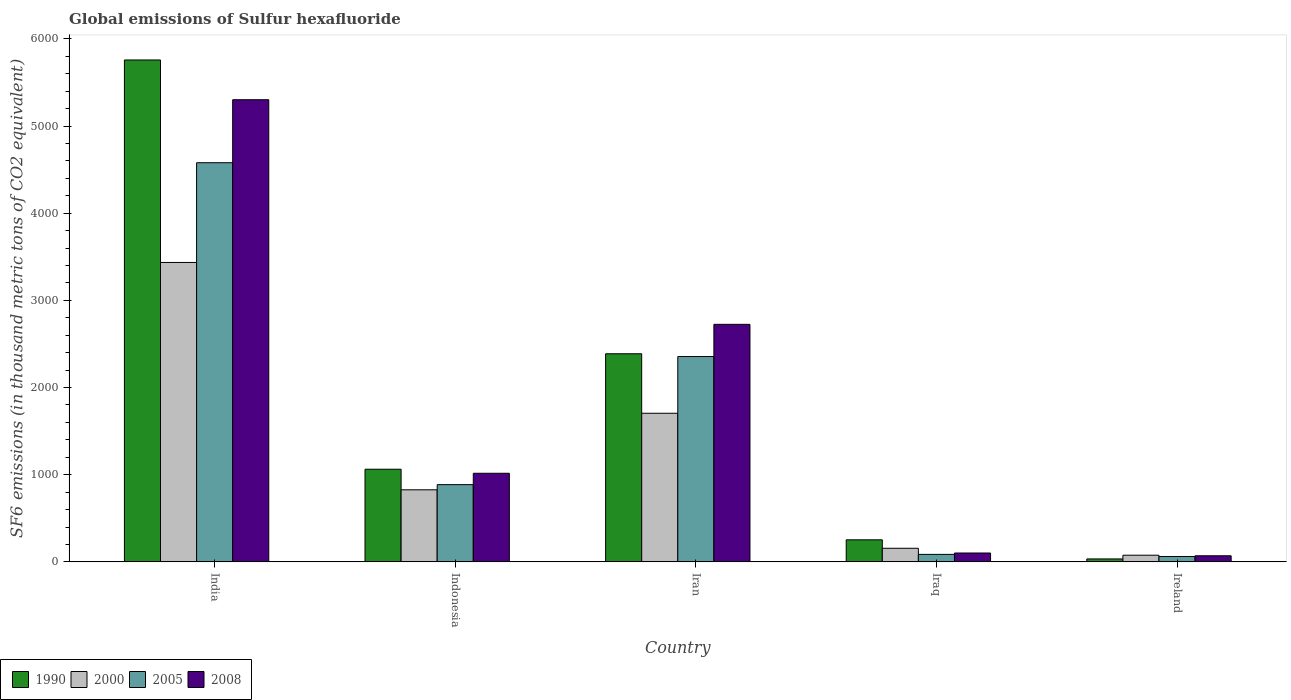How many bars are there on the 5th tick from the right?
Your response must be concise. 4. What is the label of the 4th group of bars from the left?
Give a very brief answer. Iraq. What is the global emissions of Sulfur hexafluoride in 2005 in Iran?
Your answer should be very brief. 2355.5. Across all countries, what is the maximum global emissions of Sulfur hexafluoride in 2000?
Provide a succinct answer. 3434.7. Across all countries, what is the minimum global emissions of Sulfur hexafluoride in 1990?
Keep it short and to the point. 33.8. In which country was the global emissions of Sulfur hexafluoride in 2000 maximum?
Ensure brevity in your answer.  India. In which country was the global emissions of Sulfur hexafluoride in 2000 minimum?
Offer a very short reply. Ireland. What is the total global emissions of Sulfur hexafluoride in 2000 in the graph?
Offer a terse response. 6199. What is the difference between the global emissions of Sulfur hexafluoride in 1990 in Indonesia and that in Ireland?
Provide a succinct answer. 1029. What is the difference between the global emissions of Sulfur hexafluoride in 2000 in Ireland and the global emissions of Sulfur hexafluoride in 2005 in India?
Offer a terse response. -4502.2. What is the average global emissions of Sulfur hexafluoride in 2000 per country?
Provide a short and direct response. 1239.8. What is the difference between the global emissions of Sulfur hexafluoride of/in 2005 and global emissions of Sulfur hexafluoride of/in 1990 in Iraq?
Keep it short and to the point. -166.9. In how many countries, is the global emissions of Sulfur hexafluoride in 2000 greater than 400 thousand metric tons?
Provide a succinct answer. 3. What is the ratio of the global emissions of Sulfur hexafluoride in 2008 in India to that in Indonesia?
Provide a succinct answer. 5.22. Is the global emissions of Sulfur hexafluoride in 2000 in Iran less than that in Ireland?
Make the answer very short. No. What is the difference between the highest and the second highest global emissions of Sulfur hexafluoride in 2005?
Give a very brief answer. 2223.2. What is the difference between the highest and the lowest global emissions of Sulfur hexafluoride in 2005?
Give a very brief answer. 4516.9. In how many countries, is the global emissions of Sulfur hexafluoride in 2008 greater than the average global emissions of Sulfur hexafluoride in 2008 taken over all countries?
Your response must be concise. 2. What does the 2nd bar from the left in Ireland represents?
Your answer should be compact. 2000. What does the 1st bar from the right in Indonesia represents?
Offer a terse response. 2008. Is it the case that in every country, the sum of the global emissions of Sulfur hexafluoride in 2008 and global emissions of Sulfur hexafluoride in 1990 is greater than the global emissions of Sulfur hexafluoride in 2005?
Provide a succinct answer. Yes. Are the values on the major ticks of Y-axis written in scientific E-notation?
Provide a succinct answer. No. How are the legend labels stacked?
Offer a terse response. Horizontal. What is the title of the graph?
Make the answer very short. Global emissions of Sulfur hexafluoride. Does "2007" appear as one of the legend labels in the graph?
Ensure brevity in your answer.  No. What is the label or title of the X-axis?
Offer a very short reply. Country. What is the label or title of the Y-axis?
Your answer should be compact. SF6 emissions (in thousand metric tons of CO2 equivalent). What is the SF6 emissions (in thousand metric tons of CO2 equivalent) in 1990 in India?
Keep it short and to the point. 5757.5. What is the SF6 emissions (in thousand metric tons of CO2 equivalent) of 2000 in India?
Your answer should be very brief. 3434.7. What is the SF6 emissions (in thousand metric tons of CO2 equivalent) in 2005 in India?
Your response must be concise. 4578.7. What is the SF6 emissions (in thousand metric tons of CO2 equivalent) in 2008 in India?
Give a very brief answer. 5301.4. What is the SF6 emissions (in thousand metric tons of CO2 equivalent) in 1990 in Indonesia?
Give a very brief answer. 1062.8. What is the SF6 emissions (in thousand metric tons of CO2 equivalent) of 2000 in Indonesia?
Offer a very short reply. 826.8. What is the SF6 emissions (in thousand metric tons of CO2 equivalent) in 2005 in Indonesia?
Your answer should be compact. 886.1. What is the SF6 emissions (in thousand metric tons of CO2 equivalent) of 2008 in Indonesia?
Your answer should be compact. 1016.4. What is the SF6 emissions (in thousand metric tons of CO2 equivalent) in 1990 in Iran?
Provide a succinct answer. 2387.3. What is the SF6 emissions (in thousand metric tons of CO2 equivalent) in 2000 in Iran?
Provide a short and direct response. 1704.9. What is the SF6 emissions (in thousand metric tons of CO2 equivalent) in 2005 in Iran?
Your answer should be compact. 2355.5. What is the SF6 emissions (in thousand metric tons of CO2 equivalent) in 2008 in Iran?
Make the answer very short. 2724.9. What is the SF6 emissions (in thousand metric tons of CO2 equivalent) in 1990 in Iraq?
Offer a very short reply. 252.9. What is the SF6 emissions (in thousand metric tons of CO2 equivalent) of 2000 in Iraq?
Your answer should be compact. 156.1. What is the SF6 emissions (in thousand metric tons of CO2 equivalent) in 2008 in Iraq?
Give a very brief answer. 101.7. What is the SF6 emissions (in thousand metric tons of CO2 equivalent) in 1990 in Ireland?
Make the answer very short. 33.8. What is the SF6 emissions (in thousand metric tons of CO2 equivalent) of 2000 in Ireland?
Provide a succinct answer. 76.5. What is the SF6 emissions (in thousand metric tons of CO2 equivalent) of 2005 in Ireland?
Keep it short and to the point. 61.8. What is the SF6 emissions (in thousand metric tons of CO2 equivalent) in 2008 in Ireland?
Give a very brief answer. 69.9. Across all countries, what is the maximum SF6 emissions (in thousand metric tons of CO2 equivalent) in 1990?
Offer a very short reply. 5757.5. Across all countries, what is the maximum SF6 emissions (in thousand metric tons of CO2 equivalent) in 2000?
Provide a succinct answer. 3434.7. Across all countries, what is the maximum SF6 emissions (in thousand metric tons of CO2 equivalent) of 2005?
Ensure brevity in your answer.  4578.7. Across all countries, what is the maximum SF6 emissions (in thousand metric tons of CO2 equivalent) in 2008?
Give a very brief answer. 5301.4. Across all countries, what is the minimum SF6 emissions (in thousand metric tons of CO2 equivalent) of 1990?
Give a very brief answer. 33.8. Across all countries, what is the minimum SF6 emissions (in thousand metric tons of CO2 equivalent) in 2000?
Your response must be concise. 76.5. Across all countries, what is the minimum SF6 emissions (in thousand metric tons of CO2 equivalent) in 2005?
Ensure brevity in your answer.  61.8. Across all countries, what is the minimum SF6 emissions (in thousand metric tons of CO2 equivalent) in 2008?
Your answer should be compact. 69.9. What is the total SF6 emissions (in thousand metric tons of CO2 equivalent) of 1990 in the graph?
Your answer should be very brief. 9494.3. What is the total SF6 emissions (in thousand metric tons of CO2 equivalent) in 2000 in the graph?
Make the answer very short. 6199. What is the total SF6 emissions (in thousand metric tons of CO2 equivalent) of 2005 in the graph?
Keep it short and to the point. 7968.1. What is the total SF6 emissions (in thousand metric tons of CO2 equivalent) in 2008 in the graph?
Give a very brief answer. 9214.3. What is the difference between the SF6 emissions (in thousand metric tons of CO2 equivalent) in 1990 in India and that in Indonesia?
Offer a very short reply. 4694.7. What is the difference between the SF6 emissions (in thousand metric tons of CO2 equivalent) of 2000 in India and that in Indonesia?
Keep it short and to the point. 2607.9. What is the difference between the SF6 emissions (in thousand metric tons of CO2 equivalent) in 2005 in India and that in Indonesia?
Keep it short and to the point. 3692.6. What is the difference between the SF6 emissions (in thousand metric tons of CO2 equivalent) in 2008 in India and that in Indonesia?
Your response must be concise. 4285. What is the difference between the SF6 emissions (in thousand metric tons of CO2 equivalent) in 1990 in India and that in Iran?
Your answer should be compact. 3370.2. What is the difference between the SF6 emissions (in thousand metric tons of CO2 equivalent) in 2000 in India and that in Iran?
Your answer should be very brief. 1729.8. What is the difference between the SF6 emissions (in thousand metric tons of CO2 equivalent) of 2005 in India and that in Iran?
Make the answer very short. 2223.2. What is the difference between the SF6 emissions (in thousand metric tons of CO2 equivalent) of 2008 in India and that in Iran?
Your answer should be very brief. 2576.5. What is the difference between the SF6 emissions (in thousand metric tons of CO2 equivalent) of 1990 in India and that in Iraq?
Give a very brief answer. 5504.6. What is the difference between the SF6 emissions (in thousand metric tons of CO2 equivalent) of 2000 in India and that in Iraq?
Your response must be concise. 3278.6. What is the difference between the SF6 emissions (in thousand metric tons of CO2 equivalent) of 2005 in India and that in Iraq?
Give a very brief answer. 4492.7. What is the difference between the SF6 emissions (in thousand metric tons of CO2 equivalent) of 2008 in India and that in Iraq?
Provide a short and direct response. 5199.7. What is the difference between the SF6 emissions (in thousand metric tons of CO2 equivalent) of 1990 in India and that in Ireland?
Make the answer very short. 5723.7. What is the difference between the SF6 emissions (in thousand metric tons of CO2 equivalent) of 2000 in India and that in Ireland?
Your answer should be very brief. 3358.2. What is the difference between the SF6 emissions (in thousand metric tons of CO2 equivalent) of 2005 in India and that in Ireland?
Provide a short and direct response. 4516.9. What is the difference between the SF6 emissions (in thousand metric tons of CO2 equivalent) in 2008 in India and that in Ireland?
Provide a short and direct response. 5231.5. What is the difference between the SF6 emissions (in thousand metric tons of CO2 equivalent) of 1990 in Indonesia and that in Iran?
Your answer should be very brief. -1324.5. What is the difference between the SF6 emissions (in thousand metric tons of CO2 equivalent) in 2000 in Indonesia and that in Iran?
Make the answer very short. -878.1. What is the difference between the SF6 emissions (in thousand metric tons of CO2 equivalent) of 2005 in Indonesia and that in Iran?
Offer a very short reply. -1469.4. What is the difference between the SF6 emissions (in thousand metric tons of CO2 equivalent) of 2008 in Indonesia and that in Iran?
Your answer should be very brief. -1708.5. What is the difference between the SF6 emissions (in thousand metric tons of CO2 equivalent) of 1990 in Indonesia and that in Iraq?
Offer a terse response. 809.9. What is the difference between the SF6 emissions (in thousand metric tons of CO2 equivalent) of 2000 in Indonesia and that in Iraq?
Make the answer very short. 670.7. What is the difference between the SF6 emissions (in thousand metric tons of CO2 equivalent) in 2005 in Indonesia and that in Iraq?
Offer a very short reply. 800.1. What is the difference between the SF6 emissions (in thousand metric tons of CO2 equivalent) of 2008 in Indonesia and that in Iraq?
Keep it short and to the point. 914.7. What is the difference between the SF6 emissions (in thousand metric tons of CO2 equivalent) of 1990 in Indonesia and that in Ireland?
Your answer should be compact. 1029. What is the difference between the SF6 emissions (in thousand metric tons of CO2 equivalent) in 2000 in Indonesia and that in Ireland?
Offer a terse response. 750.3. What is the difference between the SF6 emissions (in thousand metric tons of CO2 equivalent) of 2005 in Indonesia and that in Ireland?
Your answer should be compact. 824.3. What is the difference between the SF6 emissions (in thousand metric tons of CO2 equivalent) in 2008 in Indonesia and that in Ireland?
Your answer should be very brief. 946.5. What is the difference between the SF6 emissions (in thousand metric tons of CO2 equivalent) in 1990 in Iran and that in Iraq?
Offer a terse response. 2134.4. What is the difference between the SF6 emissions (in thousand metric tons of CO2 equivalent) in 2000 in Iran and that in Iraq?
Your answer should be very brief. 1548.8. What is the difference between the SF6 emissions (in thousand metric tons of CO2 equivalent) in 2005 in Iran and that in Iraq?
Offer a terse response. 2269.5. What is the difference between the SF6 emissions (in thousand metric tons of CO2 equivalent) of 2008 in Iran and that in Iraq?
Provide a short and direct response. 2623.2. What is the difference between the SF6 emissions (in thousand metric tons of CO2 equivalent) of 1990 in Iran and that in Ireland?
Keep it short and to the point. 2353.5. What is the difference between the SF6 emissions (in thousand metric tons of CO2 equivalent) of 2000 in Iran and that in Ireland?
Your response must be concise. 1628.4. What is the difference between the SF6 emissions (in thousand metric tons of CO2 equivalent) of 2005 in Iran and that in Ireland?
Make the answer very short. 2293.7. What is the difference between the SF6 emissions (in thousand metric tons of CO2 equivalent) of 2008 in Iran and that in Ireland?
Provide a succinct answer. 2655. What is the difference between the SF6 emissions (in thousand metric tons of CO2 equivalent) of 1990 in Iraq and that in Ireland?
Provide a short and direct response. 219.1. What is the difference between the SF6 emissions (in thousand metric tons of CO2 equivalent) in 2000 in Iraq and that in Ireland?
Provide a succinct answer. 79.6. What is the difference between the SF6 emissions (in thousand metric tons of CO2 equivalent) of 2005 in Iraq and that in Ireland?
Offer a terse response. 24.2. What is the difference between the SF6 emissions (in thousand metric tons of CO2 equivalent) in 2008 in Iraq and that in Ireland?
Give a very brief answer. 31.8. What is the difference between the SF6 emissions (in thousand metric tons of CO2 equivalent) of 1990 in India and the SF6 emissions (in thousand metric tons of CO2 equivalent) of 2000 in Indonesia?
Keep it short and to the point. 4930.7. What is the difference between the SF6 emissions (in thousand metric tons of CO2 equivalent) in 1990 in India and the SF6 emissions (in thousand metric tons of CO2 equivalent) in 2005 in Indonesia?
Your answer should be very brief. 4871.4. What is the difference between the SF6 emissions (in thousand metric tons of CO2 equivalent) in 1990 in India and the SF6 emissions (in thousand metric tons of CO2 equivalent) in 2008 in Indonesia?
Your answer should be very brief. 4741.1. What is the difference between the SF6 emissions (in thousand metric tons of CO2 equivalent) in 2000 in India and the SF6 emissions (in thousand metric tons of CO2 equivalent) in 2005 in Indonesia?
Offer a very short reply. 2548.6. What is the difference between the SF6 emissions (in thousand metric tons of CO2 equivalent) in 2000 in India and the SF6 emissions (in thousand metric tons of CO2 equivalent) in 2008 in Indonesia?
Your answer should be very brief. 2418.3. What is the difference between the SF6 emissions (in thousand metric tons of CO2 equivalent) of 2005 in India and the SF6 emissions (in thousand metric tons of CO2 equivalent) of 2008 in Indonesia?
Your answer should be compact. 3562.3. What is the difference between the SF6 emissions (in thousand metric tons of CO2 equivalent) of 1990 in India and the SF6 emissions (in thousand metric tons of CO2 equivalent) of 2000 in Iran?
Your answer should be very brief. 4052.6. What is the difference between the SF6 emissions (in thousand metric tons of CO2 equivalent) in 1990 in India and the SF6 emissions (in thousand metric tons of CO2 equivalent) in 2005 in Iran?
Provide a succinct answer. 3402. What is the difference between the SF6 emissions (in thousand metric tons of CO2 equivalent) of 1990 in India and the SF6 emissions (in thousand metric tons of CO2 equivalent) of 2008 in Iran?
Offer a terse response. 3032.6. What is the difference between the SF6 emissions (in thousand metric tons of CO2 equivalent) in 2000 in India and the SF6 emissions (in thousand metric tons of CO2 equivalent) in 2005 in Iran?
Make the answer very short. 1079.2. What is the difference between the SF6 emissions (in thousand metric tons of CO2 equivalent) of 2000 in India and the SF6 emissions (in thousand metric tons of CO2 equivalent) of 2008 in Iran?
Make the answer very short. 709.8. What is the difference between the SF6 emissions (in thousand metric tons of CO2 equivalent) of 2005 in India and the SF6 emissions (in thousand metric tons of CO2 equivalent) of 2008 in Iran?
Give a very brief answer. 1853.8. What is the difference between the SF6 emissions (in thousand metric tons of CO2 equivalent) of 1990 in India and the SF6 emissions (in thousand metric tons of CO2 equivalent) of 2000 in Iraq?
Provide a short and direct response. 5601.4. What is the difference between the SF6 emissions (in thousand metric tons of CO2 equivalent) of 1990 in India and the SF6 emissions (in thousand metric tons of CO2 equivalent) of 2005 in Iraq?
Provide a short and direct response. 5671.5. What is the difference between the SF6 emissions (in thousand metric tons of CO2 equivalent) in 1990 in India and the SF6 emissions (in thousand metric tons of CO2 equivalent) in 2008 in Iraq?
Your answer should be compact. 5655.8. What is the difference between the SF6 emissions (in thousand metric tons of CO2 equivalent) in 2000 in India and the SF6 emissions (in thousand metric tons of CO2 equivalent) in 2005 in Iraq?
Your answer should be compact. 3348.7. What is the difference between the SF6 emissions (in thousand metric tons of CO2 equivalent) in 2000 in India and the SF6 emissions (in thousand metric tons of CO2 equivalent) in 2008 in Iraq?
Your response must be concise. 3333. What is the difference between the SF6 emissions (in thousand metric tons of CO2 equivalent) of 2005 in India and the SF6 emissions (in thousand metric tons of CO2 equivalent) of 2008 in Iraq?
Your response must be concise. 4477. What is the difference between the SF6 emissions (in thousand metric tons of CO2 equivalent) in 1990 in India and the SF6 emissions (in thousand metric tons of CO2 equivalent) in 2000 in Ireland?
Your response must be concise. 5681. What is the difference between the SF6 emissions (in thousand metric tons of CO2 equivalent) of 1990 in India and the SF6 emissions (in thousand metric tons of CO2 equivalent) of 2005 in Ireland?
Your response must be concise. 5695.7. What is the difference between the SF6 emissions (in thousand metric tons of CO2 equivalent) in 1990 in India and the SF6 emissions (in thousand metric tons of CO2 equivalent) in 2008 in Ireland?
Your answer should be compact. 5687.6. What is the difference between the SF6 emissions (in thousand metric tons of CO2 equivalent) in 2000 in India and the SF6 emissions (in thousand metric tons of CO2 equivalent) in 2005 in Ireland?
Give a very brief answer. 3372.9. What is the difference between the SF6 emissions (in thousand metric tons of CO2 equivalent) of 2000 in India and the SF6 emissions (in thousand metric tons of CO2 equivalent) of 2008 in Ireland?
Your answer should be very brief. 3364.8. What is the difference between the SF6 emissions (in thousand metric tons of CO2 equivalent) of 2005 in India and the SF6 emissions (in thousand metric tons of CO2 equivalent) of 2008 in Ireland?
Ensure brevity in your answer.  4508.8. What is the difference between the SF6 emissions (in thousand metric tons of CO2 equivalent) of 1990 in Indonesia and the SF6 emissions (in thousand metric tons of CO2 equivalent) of 2000 in Iran?
Your response must be concise. -642.1. What is the difference between the SF6 emissions (in thousand metric tons of CO2 equivalent) in 1990 in Indonesia and the SF6 emissions (in thousand metric tons of CO2 equivalent) in 2005 in Iran?
Provide a short and direct response. -1292.7. What is the difference between the SF6 emissions (in thousand metric tons of CO2 equivalent) of 1990 in Indonesia and the SF6 emissions (in thousand metric tons of CO2 equivalent) of 2008 in Iran?
Your response must be concise. -1662.1. What is the difference between the SF6 emissions (in thousand metric tons of CO2 equivalent) of 2000 in Indonesia and the SF6 emissions (in thousand metric tons of CO2 equivalent) of 2005 in Iran?
Your answer should be very brief. -1528.7. What is the difference between the SF6 emissions (in thousand metric tons of CO2 equivalent) of 2000 in Indonesia and the SF6 emissions (in thousand metric tons of CO2 equivalent) of 2008 in Iran?
Your answer should be very brief. -1898.1. What is the difference between the SF6 emissions (in thousand metric tons of CO2 equivalent) in 2005 in Indonesia and the SF6 emissions (in thousand metric tons of CO2 equivalent) in 2008 in Iran?
Your answer should be compact. -1838.8. What is the difference between the SF6 emissions (in thousand metric tons of CO2 equivalent) in 1990 in Indonesia and the SF6 emissions (in thousand metric tons of CO2 equivalent) in 2000 in Iraq?
Provide a succinct answer. 906.7. What is the difference between the SF6 emissions (in thousand metric tons of CO2 equivalent) of 1990 in Indonesia and the SF6 emissions (in thousand metric tons of CO2 equivalent) of 2005 in Iraq?
Your response must be concise. 976.8. What is the difference between the SF6 emissions (in thousand metric tons of CO2 equivalent) in 1990 in Indonesia and the SF6 emissions (in thousand metric tons of CO2 equivalent) in 2008 in Iraq?
Offer a terse response. 961.1. What is the difference between the SF6 emissions (in thousand metric tons of CO2 equivalent) of 2000 in Indonesia and the SF6 emissions (in thousand metric tons of CO2 equivalent) of 2005 in Iraq?
Provide a short and direct response. 740.8. What is the difference between the SF6 emissions (in thousand metric tons of CO2 equivalent) in 2000 in Indonesia and the SF6 emissions (in thousand metric tons of CO2 equivalent) in 2008 in Iraq?
Make the answer very short. 725.1. What is the difference between the SF6 emissions (in thousand metric tons of CO2 equivalent) in 2005 in Indonesia and the SF6 emissions (in thousand metric tons of CO2 equivalent) in 2008 in Iraq?
Offer a terse response. 784.4. What is the difference between the SF6 emissions (in thousand metric tons of CO2 equivalent) in 1990 in Indonesia and the SF6 emissions (in thousand metric tons of CO2 equivalent) in 2000 in Ireland?
Provide a succinct answer. 986.3. What is the difference between the SF6 emissions (in thousand metric tons of CO2 equivalent) in 1990 in Indonesia and the SF6 emissions (in thousand metric tons of CO2 equivalent) in 2005 in Ireland?
Keep it short and to the point. 1001. What is the difference between the SF6 emissions (in thousand metric tons of CO2 equivalent) in 1990 in Indonesia and the SF6 emissions (in thousand metric tons of CO2 equivalent) in 2008 in Ireland?
Make the answer very short. 992.9. What is the difference between the SF6 emissions (in thousand metric tons of CO2 equivalent) of 2000 in Indonesia and the SF6 emissions (in thousand metric tons of CO2 equivalent) of 2005 in Ireland?
Your answer should be compact. 765. What is the difference between the SF6 emissions (in thousand metric tons of CO2 equivalent) of 2000 in Indonesia and the SF6 emissions (in thousand metric tons of CO2 equivalent) of 2008 in Ireland?
Provide a succinct answer. 756.9. What is the difference between the SF6 emissions (in thousand metric tons of CO2 equivalent) in 2005 in Indonesia and the SF6 emissions (in thousand metric tons of CO2 equivalent) in 2008 in Ireland?
Offer a very short reply. 816.2. What is the difference between the SF6 emissions (in thousand metric tons of CO2 equivalent) in 1990 in Iran and the SF6 emissions (in thousand metric tons of CO2 equivalent) in 2000 in Iraq?
Ensure brevity in your answer.  2231.2. What is the difference between the SF6 emissions (in thousand metric tons of CO2 equivalent) in 1990 in Iran and the SF6 emissions (in thousand metric tons of CO2 equivalent) in 2005 in Iraq?
Your answer should be compact. 2301.3. What is the difference between the SF6 emissions (in thousand metric tons of CO2 equivalent) in 1990 in Iran and the SF6 emissions (in thousand metric tons of CO2 equivalent) in 2008 in Iraq?
Make the answer very short. 2285.6. What is the difference between the SF6 emissions (in thousand metric tons of CO2 equivalent) of 2000 in Iran and the SF6 emissions (in thousand metric tons of CO2 equivalent) of 2005 in Iraq?
Provide a short and direct response. 1618.9. What is the difference between the SF6 emissions (in thousand metric tons of CO2 equivalent) of 2000 in Iran and the SF6 emissions (in thousand metric tons of CO2 equivalent) of 2008 in Iraq?
Ensure brevity in your answer.  1603.2. What is the difference between the SF6 emissions (in thousand metric tons of CO2 equivalent) in 2005 in Iran and the SF6 emissions (in thousand metric tons of CO2 equivalent) in 2008 in Iraq?
Provide a succinct answer. 2253.8. What is the difference between the SF6 emissions (in thousand metric tons of CO2 equivalent) in 1990 in Iran and the SF6 emissions (in thousand metric tons of CO2 equivalent) in 2000 in Ireland?
Your response must be concise. 2310.8. What is the difference between the SF6 emissions (in thousand metric tons of CO2 equivalent) in 1990 in Iran and the SF6 emissions (in thousand metric tons of CO2 equivalent) in 2005 in Ireland?
Keep it short and to the point. 2325.5. What is the difference between the SF6 emissions (in thousand metric tons of CO2 equivalent) in 1990 in Iran and the SF6 emissions (in thousand metric tons of CO2 equivalent) in 2008 in Ireland?
Provide a short and direct response. 2317.4. What is the difference between the SF6 emissions (in thousand metric tons of CO2 equivalent) of 2000 in Iran and the SF6 emissions (in thousand metric tons of CO2 equivalent) of 2005 in Ireland?
Provide a succinct answer. 1643.1. What is the difference between the SF6 emissions (in thousand metric tons of CO2 equivalent) in 2000 in Iran and the SF6 emissions (in thousand metric tons of CO2 equivalent) in 2008 in Ireland?
Keep it short and to the point. 1635. What is the difference between the SF6 emissions (in thousand metric tons of CO2 equivalent) in 2005 in Iran and the SF6 emissions (in thousand metric tons of CO2 equivalent) in 2008 in Ireland?
Provide a short and direct response. 2285.6. What is the difference between the SF6 emissions (in thousand metric tons of CO2 equivalent) of 1990 in Iraq and the SF6 emissions (in thousand metric tons of CO2 equivalent) of 2000 in Ireland?
Provide a short and direct response. 176.4. What is the difference between the SF6 emissions (in thousand metric tons of CO2 equivalent) in 1990 in Iraq and the SF6 emissions (in thousand metric tons of CO2 equivalent) in 2005 in Ireland?
Your answer should be very brief. 191.1. What is the difference between the SF6 emissions (in thousand metric tons of CO2 equivalent) of 1990 in Iraq and the SF6 emissions (in thousand metric tons of CO2 equivalent) of 2008 in Ireland?
Offer a very short reply. 183. What is the difference between the SF6 emissions (in thousand metric tons of CO2 equivalent) in 2000 in Iraq and the SF6 emissions (in thousand metric tons of CO2 equivalent) in 2005 in Ireland?
Provide a short and direct response. 94.3. What is the difference between the SF6 emissions (in thousand metric tons of CO2 equivalent) in 2000 in Iraq and the SF6 emissions (in thousand metric tons of CO2 equivalent) in 2008 in Ireland?
Offer a terse response. 86.2. What is the difference between the SF6 emissions (in thousand metric tons of CO2 equivalent) in 2005 in Iraq and the SF6 emissions (in thousand metric tons of CO2 equivalent) in 2008 in Ireland?
Your answer should be compact. 16.1. What is the average SF6 emissions (in thousand metric tons of CO2 equivalent) in 1990 per country?
Offer a terse response. 1898.86. What is the average SF6 emissions (in thousand metric tons of CO2 equivalent) in 2000 per country?
Your answer should be compact. 1239.8. What is the average SF6 emissions (in thousand metric tons of CO2 equivalent) in 2005 per country?
Make the answer very short. 1593.62. What is the average SF6 emissions (in thousand metric tons of CO2 equivalent) of 2008 per country?
Your answer should be compact. 1842.86. What is the difference between the SF6 emissions (in thousand metric tons of CO2 equivalent) of 1990 and SF6 emissions (in thousand metric tons of CO2 equivalent) of 2000 in India?
Give a very brief answer. 2322.8. What is the difference between the SF6 emissions (in thousand metric tons of CO2 equivalent) in 1990 and SF6 emissions (in thousand metric tons of CO2 equivalent) in 2005 in India?
Keep it short and to the point. 1178.8. What is the difference between the SF6 emissions (in thousand metric tons of CO2 equivalent) in 1990 and SF6 emissions (in thousand metric tons of CO2 equivalent) in 2008 in India?
Provide a succinct answer. 456.1. What is the difference between the SF6 emissions (in thousand metric tons of CO2 equivalent) of 2000 and SF6 emissions (in thousand metric tons of CO2 equivalent) of 2005 in India?
Provide a short and direct response. -1144. What is the difference between the SF6 emissions (in thousand metric tons of CO2 equivalent) in 2000 and SF6 emissions (in thousand metric tons of CO2 equivalent) in 2008 in India?
Your answer should be very brief. -1866.7. What is the difference between the SF6 emissions (in thousand metric tons of CO2 equivalent) of 2005 and SF6 emissions (in thousand metric tons of CO2 equivalent) of 2008 in India?
Your answer should be very brief. -722.7. What is the difference between the SF6 emissions (in thousand metric tons of CO2 equivalent) in 1990 and SF6 emissions (in thousand metric tons of CO2 equivalent) in 2000 in Indonesia?
Ensure brevity in your answer.  236. What is the difference between the SF6 emissions (in thousand metric tons of CO2 equivalent) in 1990 and SF6 emissions (in thousand metric tons of CO2 equivalent) in 2005 in Indonesia?
Keep it short and to the point. 176.7. What is the difference between the SF6 emissions (in thousand metric tons of CO2 equivalent) of 1990 and SF6 emissions (in thousand metric tons of CO2 equivalent) of 2008 in Indonesia?
Your answer should be compact. 46.4. What is the difference between the SF6 emissions (in thousand metric tons of CO2 equivalent) of 2000 and SF6 emissions (in thousand metric tons of CO2 equivalent) of 2005 in Indonesia?
Offer a terse response. -59.3. What is the difference between the SF6 emissions (in thousand metric tons of CO2 equivalent) of 2000 and SF6 emissions (in thousand metric tons of CO2 equivalent) of 2008 in Indonesia?
Offer a very short reply. -189.6. What is the difference between the SF6 emissions (in thousand metric tons of CO2 equivalent) of 2005 and SF6 emissions (in thousand metric tons of CO2 equivalent) of 2008 in Indonesia?
Ensure brevity in your answer.  -130.3. What is the difference between the SF6 emissions (in thousand metric tons of CO2 equivalent) in 1990 and SF6 emissions (in thousand metric tons of CO2 equivalent) in 2000 in Iran?
Provide a succinct answer. 682.4. What is the difference between the SF6 emissions (in thousand metric tons of CO2 equivalent) of 1990 and SF6 emissions (in thousand metric tons of CO2 equivalent) of 2005 in Iran?
Your answer should be compact. 31.8. What is the difference between the SF6 emissions (in thousand metric tons of CO2 equivalent) in 1990 and SF6 emissions (in thousand metric tons of CO2 equivalent) in 2008 in Iran?
Your answer should be very brief. -337.6. What is the difference between the SF6 emissions (in thousand metric tons of CO2 equivalent) of 2000 and SF6 emissions (in thousand metric tons of CO2 equivalent) of 2005 in Iran?
Your answer should be compact. -650.6. What is the difference between the SF6 emissions (in thousand metric tons of CO2 equivalent) in 2000 and SF6 emissions (in thousand metric tons of CO2 equivalent) in 2008 in Iran?
Provide a short and direct response. -1020. What is the difference between the SF6 emissions (in thousand metric tons of CO2 equivalent) of 2005 and SF6 emissions (in thousand metric tons of CO2 equivalent) of 2008 in Iran?
Provide a succinct answer. -369.4. What is the difference between the SF6 emissions (in thousand metric tons of CO2 equivalent) of 1990 and SF6 emissions (in thousand metric tons of CO2 equivalent) of 2000 in Iraq?
Ensure brevity in your answer.  96.8. What is the difference between the SF6 emissions (in thousand metric tons of CO2 equivalent) in 1990 and SF6 emissions (in thousand metric tons of CO2 equivalent) in 2005 in Iraq?
Offer a terse response. 166.9. What is the difference between the SF6 emissions (in thousand metric tons of CO2 equivalent) of 1990 and SF6 emissions (in thousand metric tons of CO2 equivalent) of 2008 in Iraq?
Your answer should be very brief. 151.2. What is the difference between the SF6 emissions (in thousand metric tons of CO2 equivalent) in 2000 and SF6 emissions (in thousand metric tons of CO2 equivalent) in 2005 in Iraq?
Provide a short and direct response. 70.1. What is the difference between the SF6 emissions (in thousand metric tons of CO2 equivalent) of 2000 and SF6 emissions (in thousand metric tons of CO2 equivalent) of 2008 in Iraq?
Give a very brief answer. 54.4. What is the difference between the SF6 emissions (in thousand metric tons of CO2 equivalent) in 2005 and SF6 emissions (in thousand metric tons of CO2 equivalent) in 2008 in Iraq?
Ensure brevity in your answer.  -15.7. What is the difference between the SF6 emissions (in thousand metric tons of CO2 equivalent) in 1990 and SF6 emissions (in thousand metric tons of CO2 equivalent) in 2000 in Ireland?
Provide a short and direct response. -42.7. What is the difference between the SF6 emissions (in thousand metric tons of CO2 equivalent) in 1990 and SF6 emissions (in thousand metric tons of CO2 equivalent) in 2005 in Ireland?
Offer a terse response. -28. What is the difference between the SF6 emissions (in thousand metric tons of CO2 equivalent) in 1990 and SF6 emissions (in thousand metric tons of CO2 equivalent) in 2008 in Ireland?
Ensure brevity in your answer.  -36.1. What is the difference between the SF6 emissions (in thousand metric tons of CO2 equivalent) in 2000 and SF6 emissions (in thousand metric tons of CO2 equivalent) in 2008 in Ireland?
Your response must be concise. 6.6. What is the ratio of the SF6 emissions (in thousand metric tons of CO2 equivalent) in 1990 in India to that in Indonesia?
Make the answer very short. 5.42. What is the ratio of the SF6 emissions (in thousand metric tons of CO2 equivalent) of 2000 in India to that in Indonesia?
Ensure brevity in your answer.  4.15. What is the ratio of the SF6 emissions (in thousand metric tons of CO2 equivalent) of 2005 in India to that in Indonesia?
Offer a very short reply. 5.17. What is the ratio of the SF6 emissions (in thousand metric tons of CO2 equivalent) in 2008 in India to that in Indonesia?
Give a very brief answer. 5.22. What is the ratio of the SF6 emissions (in thousand metric tons of CO2 equivalent) in 1990 in India to that in Iran?
Keep it short and to the point. 2.41. What is the ratio of the SF6 emissions (in thousand metric tons of CO2 equivalent) of 2000 in India to that in Iran?
Give a very brief answer. 2.01. What is the ratio of the SF6 emissions (in thousand metric tons of CO2 equivalent) of 2005 in India to that in Iran?
Your answer should be compact. 1.94. What is the ratio of the SF6 emissions (in thousand metric tons of CO2 equivalent) of 2008 in India to that in Iran?
Ensure brevity in your answer.  1.95. What is the ratio of the SF6 emissions (in thousand metric tons of CO2 equivalent) in 1990 in India to that in Iraq?
Provide a short and direct response. 22.77. What is the ratio of the SF6 emissions (in thousand metric tons of CO2 equivalent) of 2000 in India to that in Iraq?
Ensure brevity in your answer.  22. What is the ratio of the SF6 emissions (in thousand metric tons of CO2 equivalent) in 2005 in India to that in Iraq?
Provide a short and direct response. 53.24. What is the ratio of the SF6 emissions (in thousand metric tons of CO2 equivalent) in 2008 in India to that in Iraq?
Give a very brief answer. 52.13. What is the ratio of the SF6 emissions (in thousand metric tons of CO2 equivalent) in 1990 in India to that in Ireland?
Provide a succinct answer. 170.34. What is the ratio of the SF6 emissions (in thousand metric tons of CO2 equivalent) in 2000 in India to that in Ireland?
Make the answer very short. 44.9. What is the ratio of the SF6 emissions (in thousand metric tons of CO2 equivalent) of 2005 in India to that in Ireland?
Provide a succinct answer. 74.09. What is the ratio of the SF6 emissions (in thousand metric tons of CO2 equivalent) in 2008 in India to that in Ireland?
Your response must be concise. 75.84. What is the ratio of the SF6 emissions (in thousand metric tons of CO2 equivalent) in 1990 in Indonesia to that in Iran?
Provide a succinct answer. 0.45. What is the ratio of the SF6 emissions (in thousand metric tons of CO2 equivalent) in 2000 in Indonesia to that in Iran?
Offer a very short reply. 0.48. What is the ratio of the SF6 emissions (in thousand metric tons of CO2 equivalent) of 2005 in Indonesia to that in Iran?
Offer a terse response. 0.38. What is the ratio of the SF6 emissions (in thousand metric tons of CO2 equivalent) in 2008 in Indonesia to that in Iran?
Offer a very short reply. 0.37. What is the ratio of the SF6 emissions (in thousand metric tons of CO2 equivalent) in 1990 in Indonesia to that in Iraq?
Provide a succinct answer. 4.2. What is the ratio of the SF6 emissions (in thousand metric tons of CO2 equivalent) in 2000 in Indonesia to that in Iraq?
Offer a very short reply. 5.3. What is the ratio of the SF6 emissions (in thousand metric tons of CO2 equivalent) of 2005 in Indonesia to that in Iraq?
Keep it short and to the point. 10.3. What is the ratio of the SF6 emissions (in thousand metric tons of CO2 equivalent) in 2008 in Indonesia to that in Iraq?
Offer a very short reply. 9.99. What is the ratio of the SF6 emissions (in thousand metric tons of CO2 equivalent) of 1990 in Indonesia to that in Ireland?
Offer a very short reply. 31.44. What is the ratio of the SF6 emissions (in thousand metric tons of CO2 equivalent) in 2000 in Indonesia to that in Ireland?
Offer a very short reply. 10.81. What is the ratio of the SF6 emissions (in thousand metric tons of CO2 equivalent) in 2005 in Indonesia to that in Ireland?
Your answer should be compact. 14.34. What is the ratio of the SF6 emissions (in thousand metric tons of CO2 equivalent) of 2008 in Indonesia to that in Ireland?
Provide a succinct answer. 14.54. What is the ratio of the SF6 emissions (in thousand metric tons of CO2 equivalent) in 1990 in Iran to that in Iraq?
Make the answer very short. 9.44. What is the ratio of the SF6 emissions (in thousand metric tons of CO2 equivalent) of 2000 in Iran to that in Iraq?
Provide a short and direct response. 10.92. What is the ratio of the SF6 emissions (in thousand metric tons of CO2 equivalent) in 2005 in Iran to that in Iraq?
Your answer should be very brief. 27.39. What is the ratio of the SF6 emissions (in thousand metric tons of CO2 equivalent) of 2008 in Iran to that in Iraq?
Your response must be concise. 26.79. What is the ratio of the SF6 emissions (in thousand metric tons of CO2 equivalent) in 1990 in Iran to that in Ireland?
Keep it short and to the point. 70.63. What is the ratio of the SF6 emissions (in thousand metric tons of CO2 equivalent) of 2000 in Iran to that in Ireland?
Offer a very short reply. 22.29. What is the ratio of the SF6 emissions (in thousand metric tons of CO2 equivalent) of 2005 in Iran to that in Ireland?
Your answer should be very brief. 38.11. What is the ratio of the SF6 emissions (in thousand metric tons of CO2 equivalent) in 2008 in Iran to that in Ireland?
Ensure brevity in your answer.  38.98. What is the ratio of the SF6 emissions (in thousand metric tons of CO2 equivalent) in 1990 in Iraq to that in Ireland?
Your answer should be compact. 7.48. What is the ratio of the SF6 emissions (in thousand metric tons of CO2 equivalent) of 2000 in Iraq to that in Ireland?
Provide a short and direct response. 2.04. What is the ratio of the SF6 emissions (in thousand metric tons of CO2 equivalent) in 2005 in Iraq to that in Ireland?
Provide a short and direct response. 1.39. What is the ratio of the SF6 emissions (in thousand metric tons of CO2 equivalent) in 2008 in Iraq to that in Ireland?
Keep it short and to the point. 1.45. What is the difference between the highest and the second highest SF6 emissions (in thousand metric tons of CO2 equivalent) of 1990?
Ensure brevity in your answer.  3370.2. What is the difference between the highest and the second highest SF6 emissions (in thousand metric tons of CO2 equivalent) of 2000?
Offer a terse response. 1729.8. What is the difference between the highest and the second highest SF6 emissions (in thousand metric tons of CO2 equivalent) in 2005?
Your answer should be very brief. 2223.2. What is the difference between the highest and the second highest SF6 emissions (in thousand metric tons of CO2 equivalent) of 2008?
Provide a short and direct response. 2576.5. What is the difference between the highest and the lowest SF6 emissions (in thousand metric tons of CO2 equivalent) in 1990?
Make the answer very short. 5723.7. What is the difference between the highest and the lowest SF6 emissions (in thousand metric tons of CO2 equivalent) of 2000?
Make the answer very short. 3358.2. What is the difference between the highest and the lowest SF6 emissions (in thousand metric tons of CO2 equivalent) of 2005?
Make the answer very short. 4516.9. What is the difference between the highest and the lowest SF6 emissions (in thousand metric tons of CO2 equivalent) of 2008?
Your response must be concise. 5231.5. 